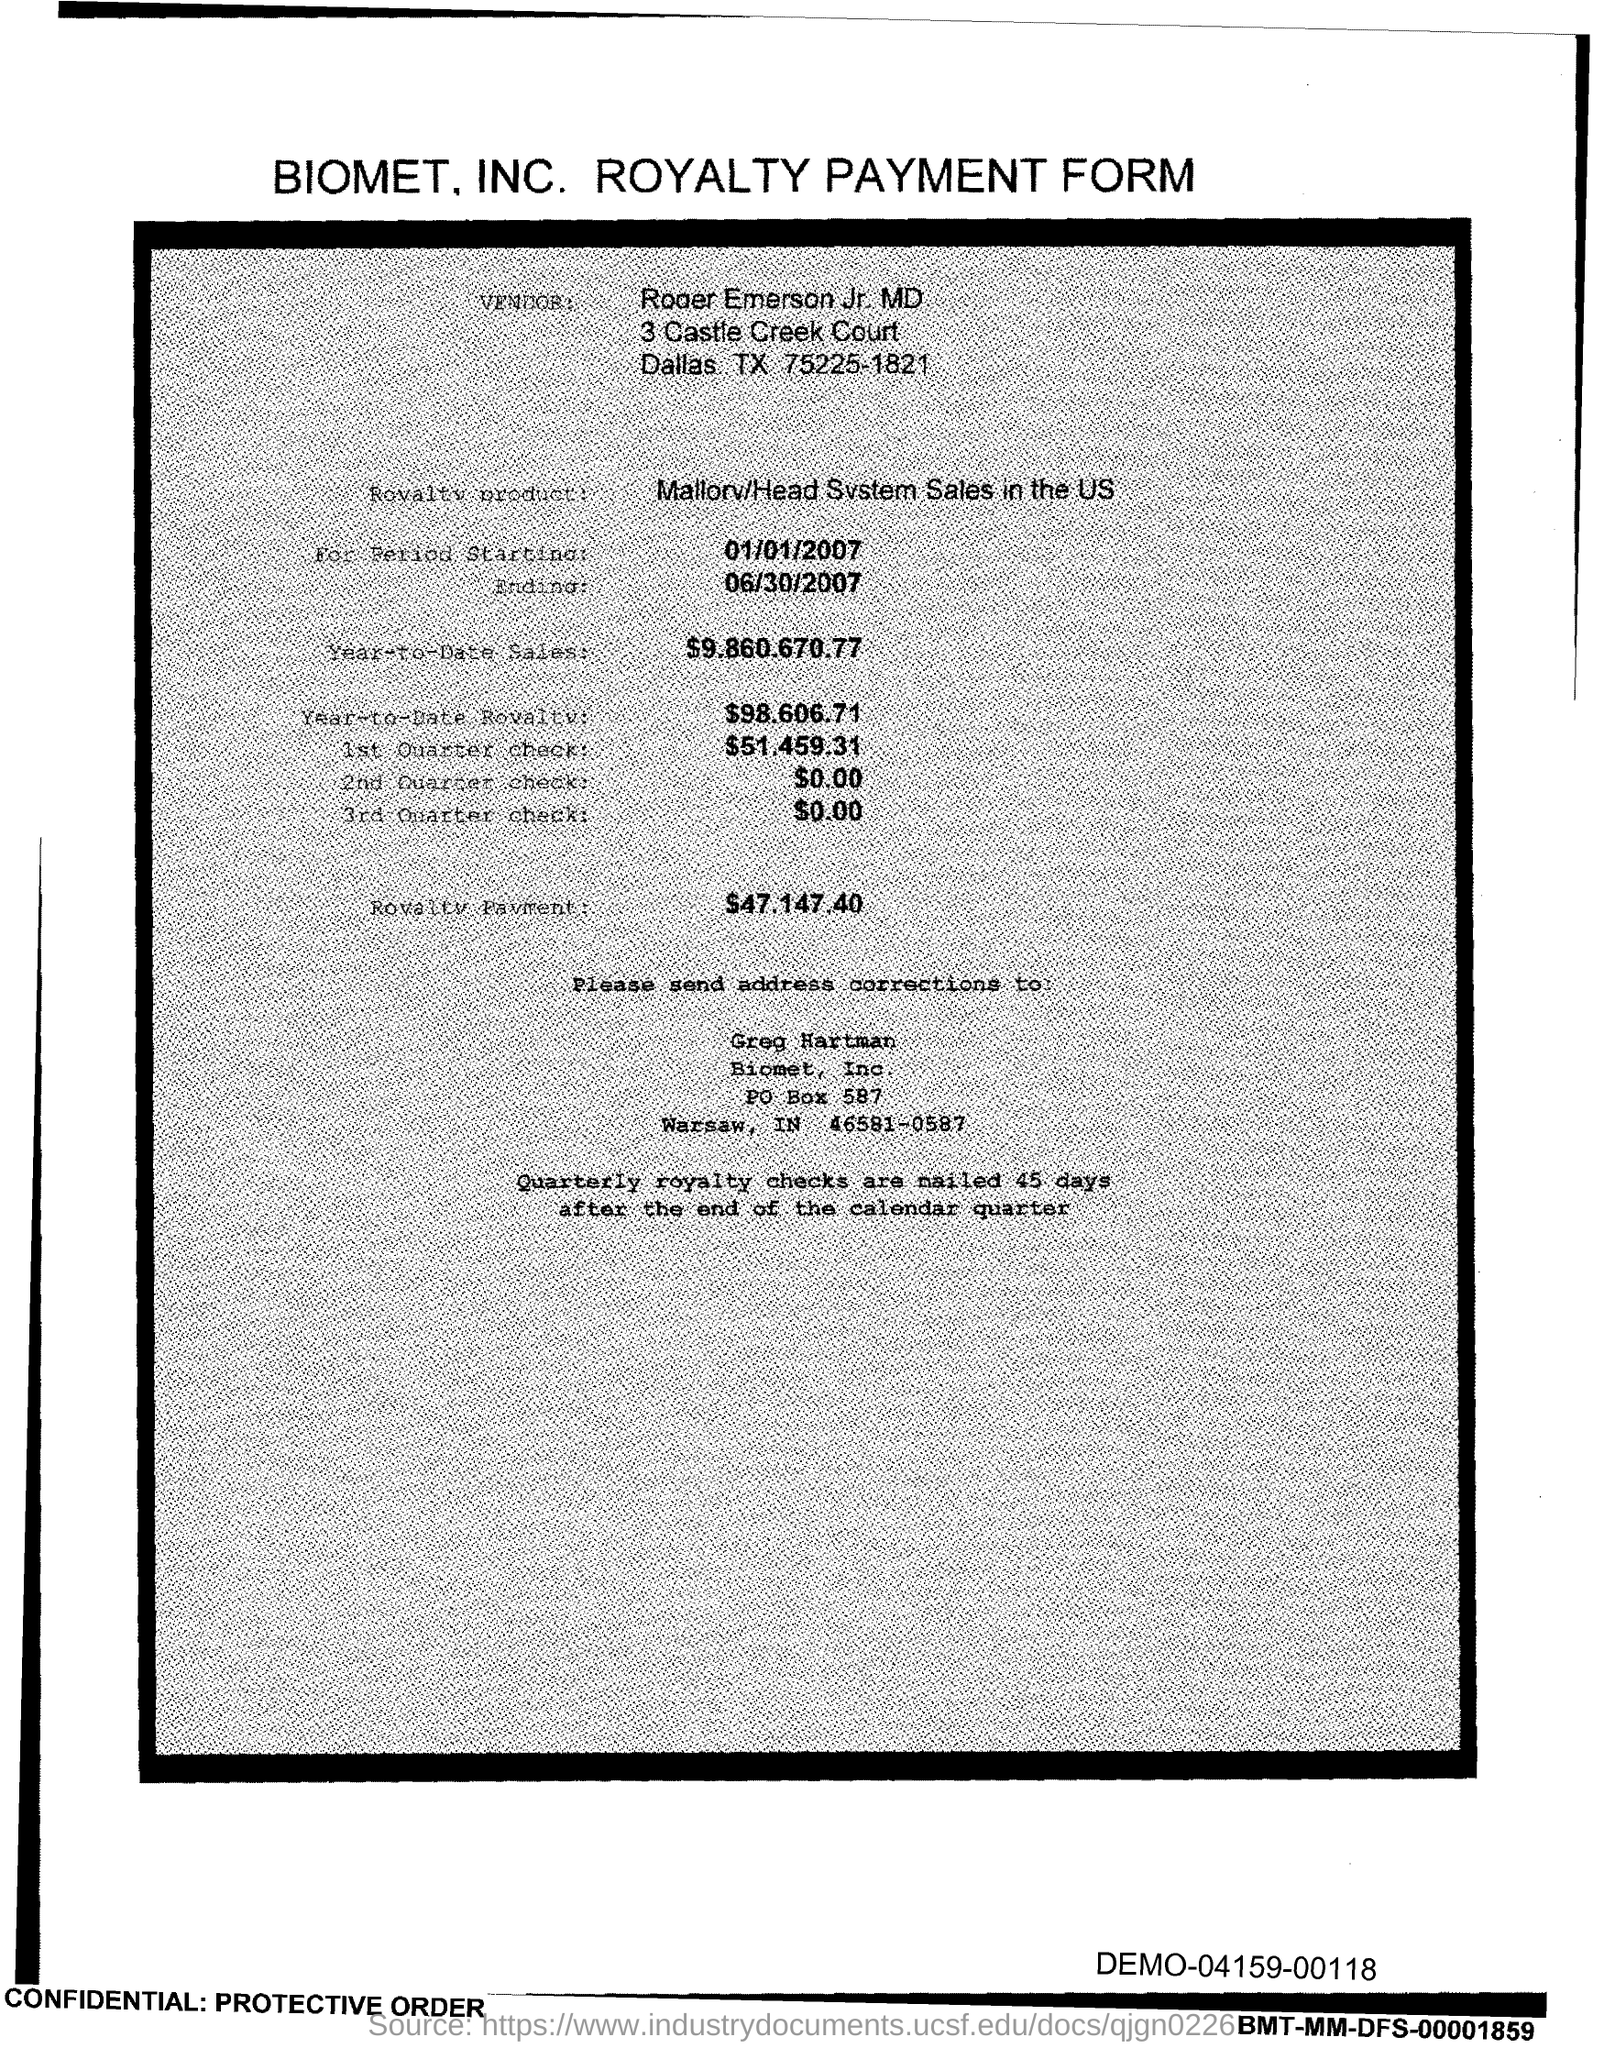What is the title of this form?
Your response must be concise. BIOMET. INC. ROYALTY PAYMENT FORM. 